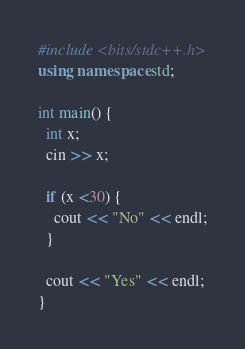<code> <loc_0><loc_0><loc_500><loc_500><_C++_>
#include <bits/stdc++.h>
using namespace std;

int main() {
  int x;
  cin >> x;

  if (x <30) {
    cout << "No" << endl;
  }

  cout << "Yes" << endl;
}
</code> 